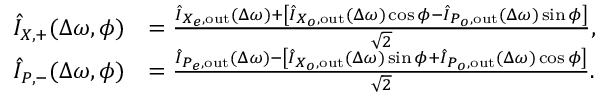<formula> <loc_0><loc_0><loc_500><loc_500>\begin{array} { r l } { \hat { I } _ { X , + } ( \Delta \omega , \phi ) } & { = \frac { \hat { I } _ { X _ { e } , o u t } ( \Delta \omega ) + \left [ \hat { I } _ { X _ { o } , o u t } ( \Delta \omega ) \cos \phi - \hat { I } _ { P _ { o } , o u t } ( \Delta \omega ) \sin \phi \right ] } { \sqrt { 2 } } , } \\ { \hat { I } _ { P , - } ( \Delta \omega , \phi ) } & { = \frac { \hat { I } _ { P _ { e } , o u t } ( \Delta \omega ) - \left [ \hat { I } _ { X _ { o } , o u t } ( \Delta \omega ) \sin \phi + \hat { I } _ { P _ { o } , o u t } ( \Delta \omega ) \cos \phi \right ] } { \sqrt { 2 } } . } \end{array}</formula> 